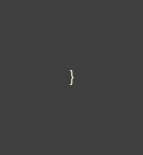<code> <loc_0><loc_0><loc_500><loc_500><_C_>}
</code> 